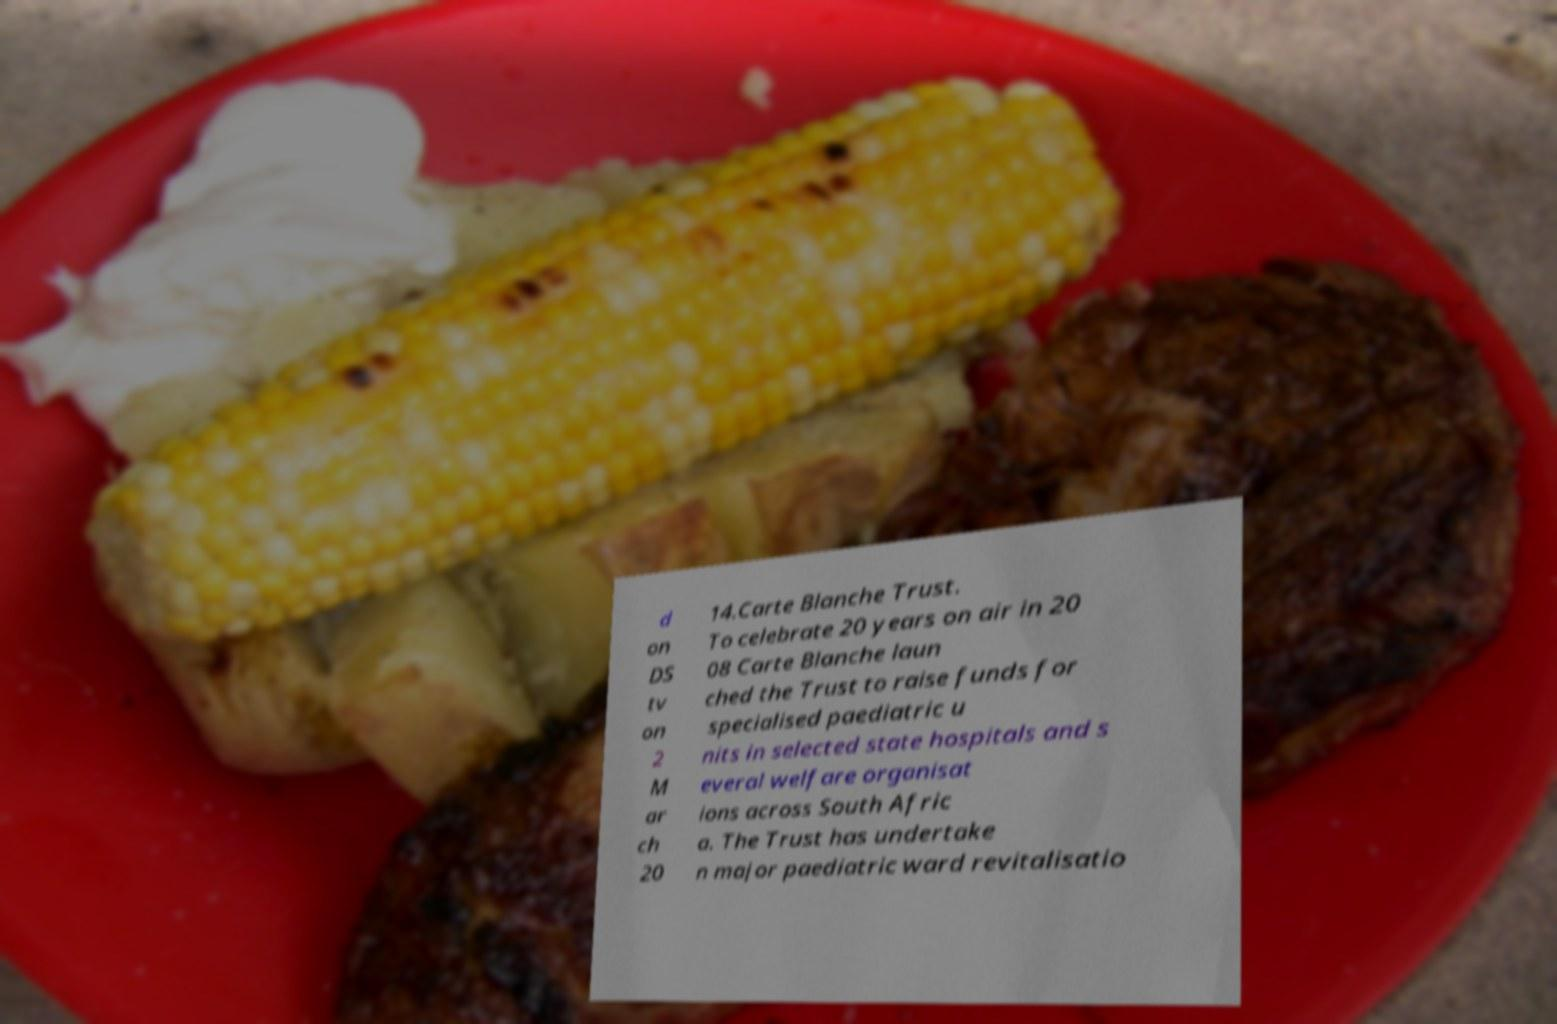What messages or text are displayed in this image? I need them in a readable, typed format. d on DS tv on 2 M ar ch 20 14.Carte Blanche Trust. To celebrate 20 years on air in 20 08 Carte Blanche laun ched the Trust to raise funds for specialised paediatric u nits in selected state hospitals and s everal welfare organisat ions across South Afric a. The Trust has undertake n major paediatric ward revitalisatio 